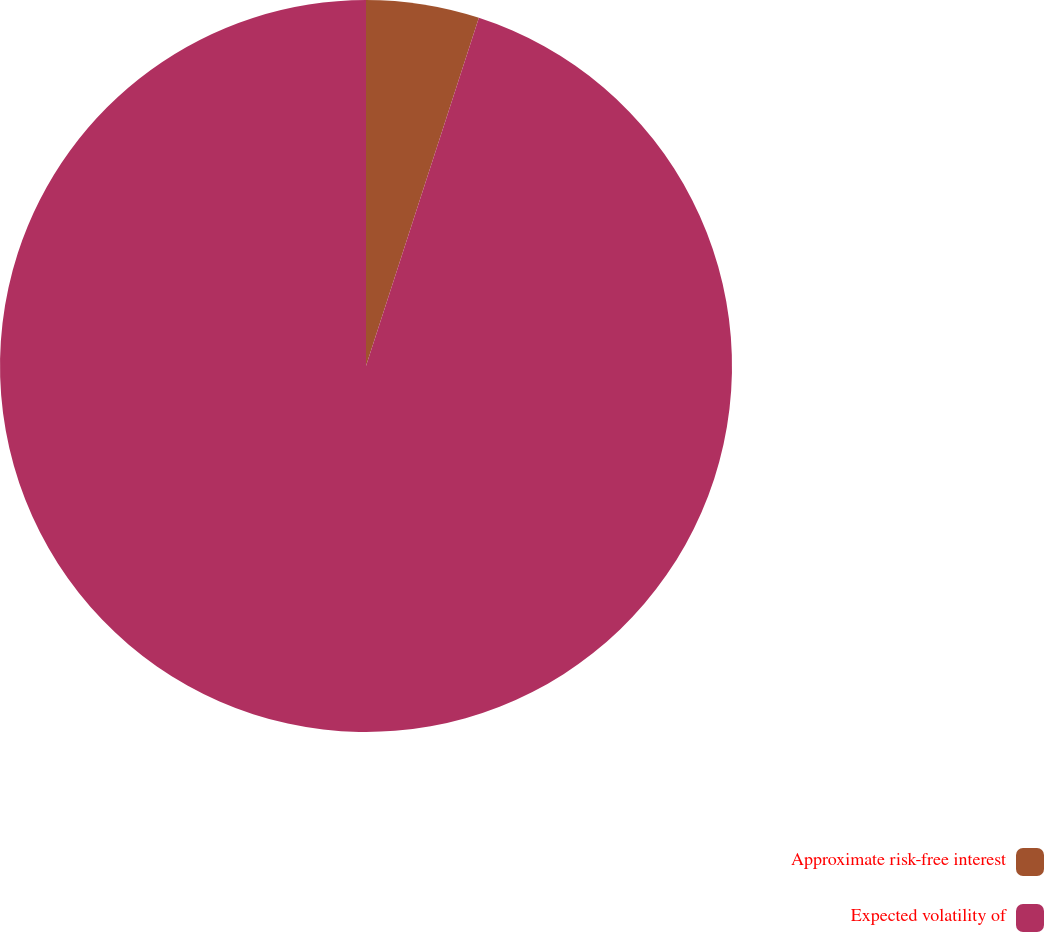Convert chart to OTSL. <chart><loc_0><loc_0><loc_500><loc_500><pie_chart><fcel>Approximate risk-free interest<fcel>Expected volatility of<nl><fcel>4.99%<fcel>95.01%<nl></chart> 